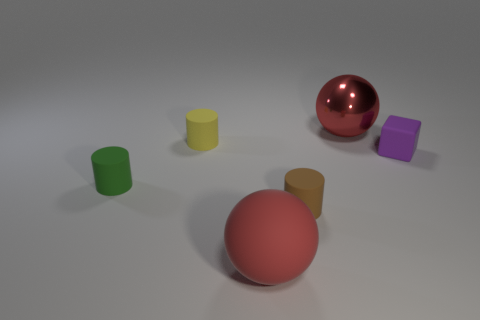Do the colors of the objects represent any common theme or category? The colors of the objects seem random and do not indicate any clear theme or category. Their vibrant tones may serve simply as a visual differentiation between each item. 